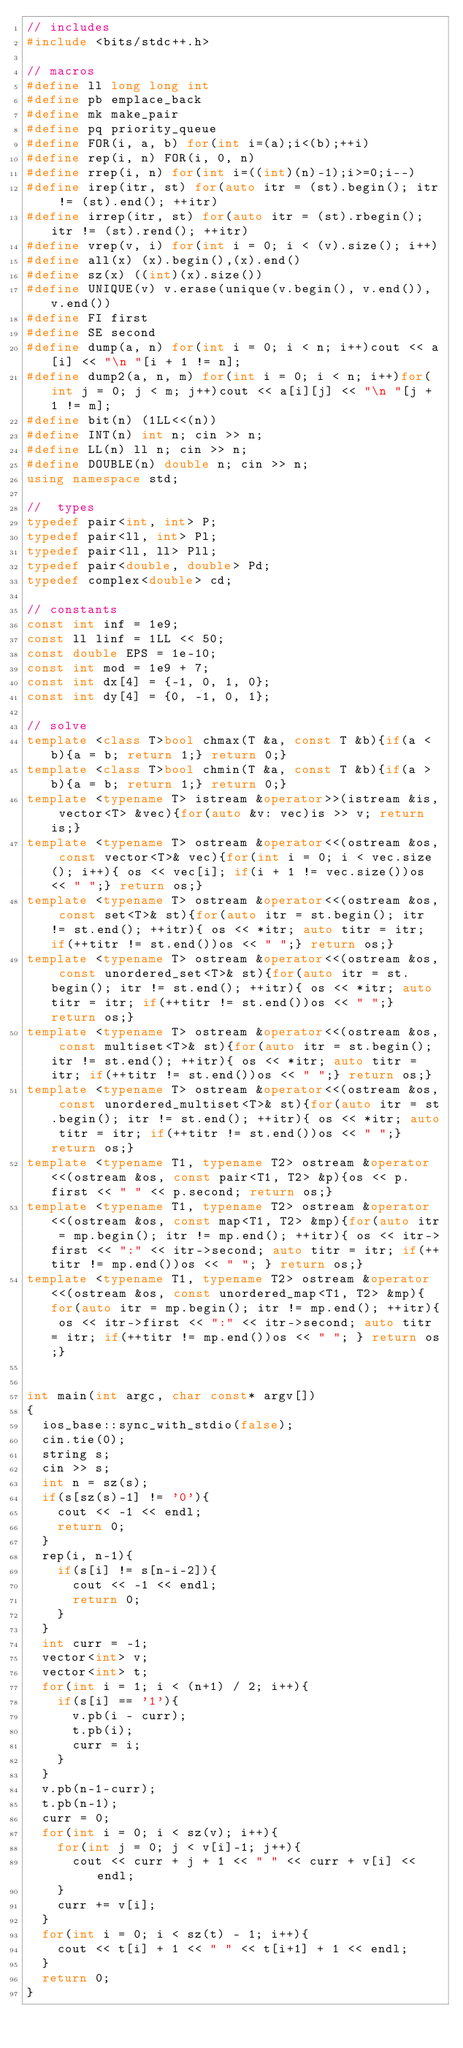Convert code to text. <code><loc_0><loc_0><loc_500><loc_500><_C++_>// includes
#include <bits/stdc++.h>

// macros
#define ll long long int
#define pb emplace_back
#define mk make_pair
#define pq priority_queue
#define FOR(i, a, b) for(int i=(a);i<(b);++i)
#define rep(i, n) FOR(i, 0, n)
#define rrep(i, n) for(int i=((int)(n)-1);i>=0;i--)
#define irep(itr, st) for(auto itr = (st).begin(); itr != (st).end(); ++itr)
#define irrep(itr, st) for(auto itr = (st).rbegin(); itr != (st).rend(); ++itr)
#define vrep(v, i) for(int i = 0; i < (v).size(); i++)
#define all(x) (x).begin(),(x).end()
#define sz(x) ((int)(x).size())
#define UNIQUE(v) v.erase(unique(v.begin(), v.end()), v.end())
#define FI first
#define SE second
#define dump(a, n) for(int i = 0; i < n; i++)cout << a[i] << "\n "[i + 1 != n];
#define dump2(a, n, m) for(int i = 0; i < n; i++)for(int j = 0; j < m; j++)cout << a[i][j] << "\n "[j + 1 != m];
#define bit(n) (1LL<<(n))
#define INT(n) int n; cin >> n;
#define LL(n) ll n; cin >> n;
#define DOUBLE(n) double n; cin >> n;
using namespace std;

//  types
typedef pair<int, int> P;
typedef pair<ll, int> Pl;
typedef pair<ll, ll> Pll;
typedef pair<double, double> Pd;
typedef complex<double> cd;
 
// constants
const int inf = 1e9;
const ll linf = 1LL << 50;
const double EPS = 1e-10;
const int mod = 1e9 + 7;
const int dx[4] = {-1, 0, 1, 0};
const int dy[4] = {0, -1, 0, 1};

// solve
template <class T>bool chmax(T &a, const T &b){if(a < b){a = b; return 1;} return 0;}
template <class T>bool chmin(T &a, const T &b){if(a > b){a = b; return 1;} return 0;}
template <typename T> istream &operator>>(istream &is, vector<T> &vec){for(auto &v: vec)is >> v; return is;}
template <typename T> ostream &operator<<(ostream &os, const vector<T>& vec){for(int i = 0; i < vec.size(); i++){ os << vec[i]; if(i + 1 != vec.size())os << " ";} return os;}
template <typename T> ostream &operator<<(ostream &os, const set<T>& st){for(auto itr = st.begin(); itr != st.end(); ++itr){ os << *itr; auto titr = itr; if(++titr != st.end())os << " ";} return os;}
template <typename T> ostream &operator<<(ostream &os, const unordered_set<T>& st){for(auto itr = st.begin(); itr != st.end(); ++itr){ os << *itr; auto titr = itr; if(++titr != st.end())os << " ";} return os;}
template <typename T> ostream &operator<<(ostream &os, const multiset<T>& st){for(auto itr = st.begin(); itr != st.end(); ++itr){ os << *itr; auto titr = itr; if(++titr != st.end())os << " ";} return os;}
template <typename T> ostream &operator<<(ostream &os, const unordered_multiset<T>& st){for(auto itr = st.begin(); itr != st.end(); ++itr){ os << *itr; auto titr = itr; if(++titr != st.end())os << " ";} return os;}
template <typename T1, typename T2> ostream &operator<<(ostream &os, const pair<T1, T2> &p){os << p.first << " " << p.second; return os;}
template <typename T1, typename T2> ostream &operator<<(ostream &os, const map<T1, T2> &mp){for(auto itr = mp.begin(); itr != mp.end(); ++itr){ os << itr->first << ":" << itr->second; auto titr = itr; if(++titr != mp.end())os << " "; } return os;}
template <typename T1, typename T2> ostream &operator<<(ostream &os, const unordered_map<T1, T2> &mp){for(auto itr = mp.begin(); itr != mp.end(); ++itr){ os << itr->first << ":" << itr->second; auto titr = itr; if(++titr != mp.end())os << " "; } return os;}


int main(int argc, char const* argv[])
{
  ios_base::sync_with_stdio(false);
  cin.tie(0);
  string s;
  cin >> s;
  int n = sz(s);
  if(s[sz(s)-1] != '0'){
    cout << -1 << endl;
    return 0;
  }
  rep(i, n-1){
    if(s[i] != s[n-i-2]){
      cout << -1 << endl;
      return 0;
    }
  }
  int curr = -1;
  vector<int> v;
  vector<int> t;
  for(int i = 1; i < (n+1) / 2; i++){
    if(s[i] == '1'){
      v.pb(i - curr);
      t.pb(i);
      curr = i;
    }
  }
  v.pb(n-1-curr);
  t.pb(n-1);
  curr = 0;
  for(int i = 0; i < sz(v); i++){
    for(int j = 0; j < v[i]-1; j++){
      cout << curr + j + 1 << " " << curr + v[i] << endl;
    }
    curr += v[i];
  }
  for(int i = 0; i < sz(t) - 1; i++){
    cout << t[i] + 1 << " " << t[i+1] + 1 << endl;
  }
  return 0;
}
</code> 